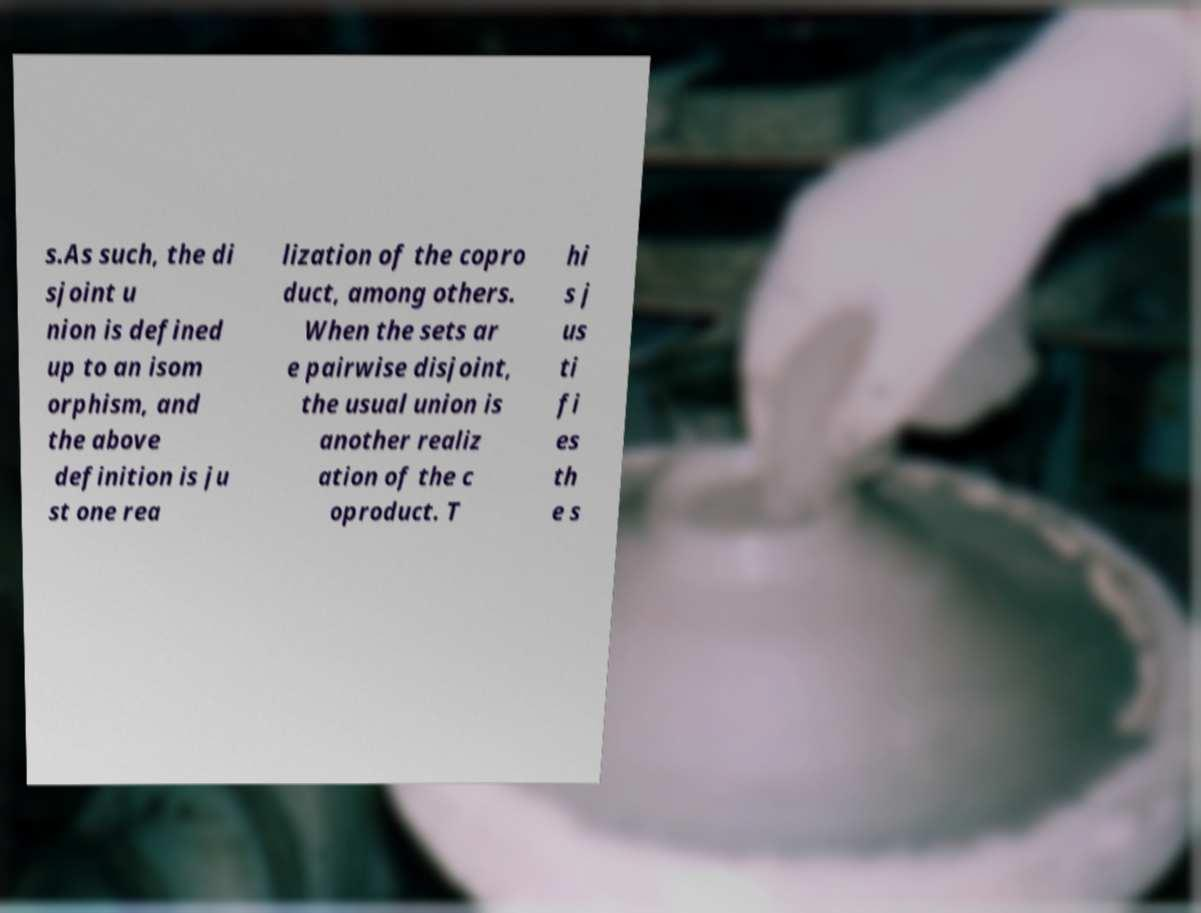Please identify and transcribe the text found in this image. s.As such, the di sjoint u nion is defined up to an isom orphism, and the above definition is ju st one rea lization of the copro duct, among others. When the sets ar e pairwise disjoint, the usual union is another realiz ation of the c oproduct. T hi s j us ti fi es th e s 